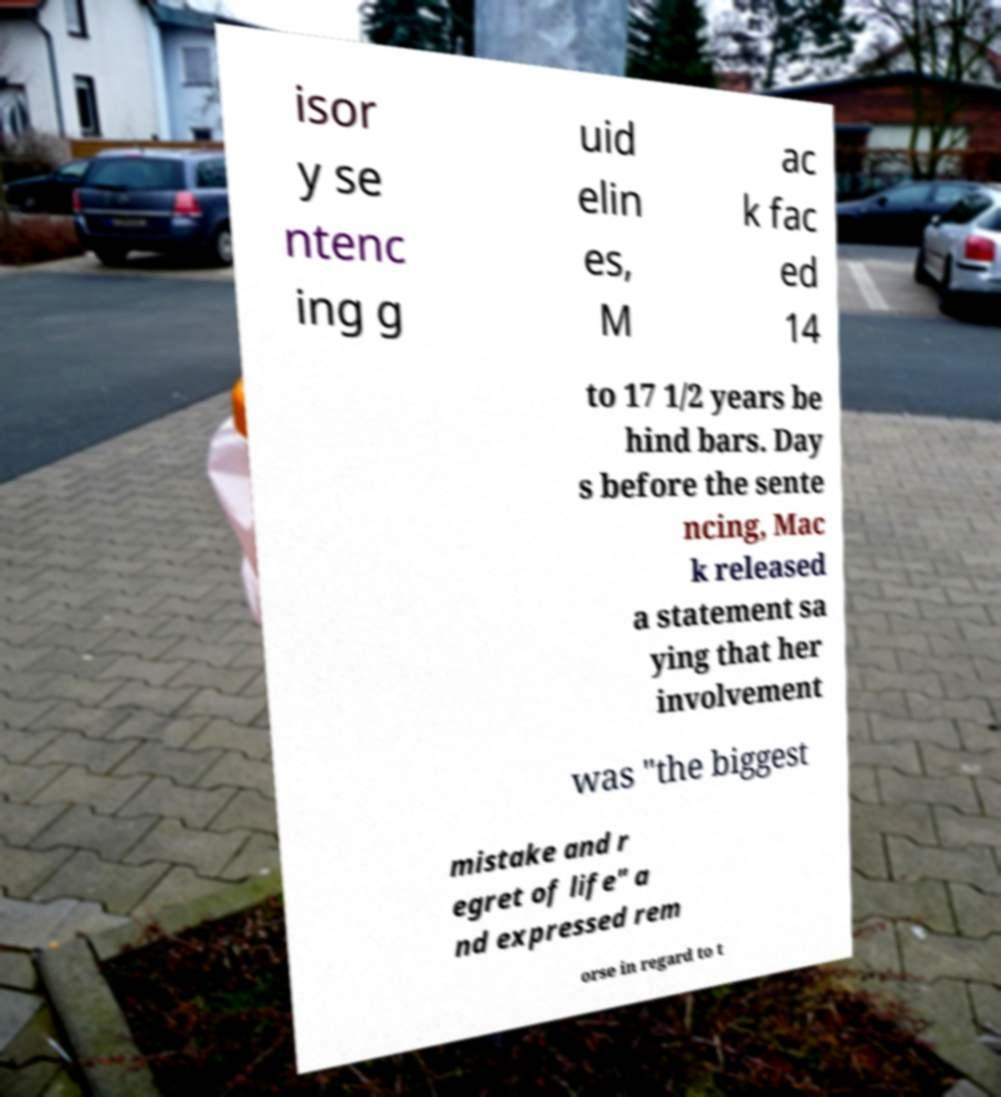There's text embedded in this image that I need extracted. Can you transcribe it verbatim? isor y se ntenc ing g uid elin es, M ac k fac ed 14 to 17 1/2 years be hind bars. Day s before the sente ncing, Mac k released a statement sa ying that her involvement was "the biggest mistake and r egret of life" a nd expressed rem orse in regard to t 